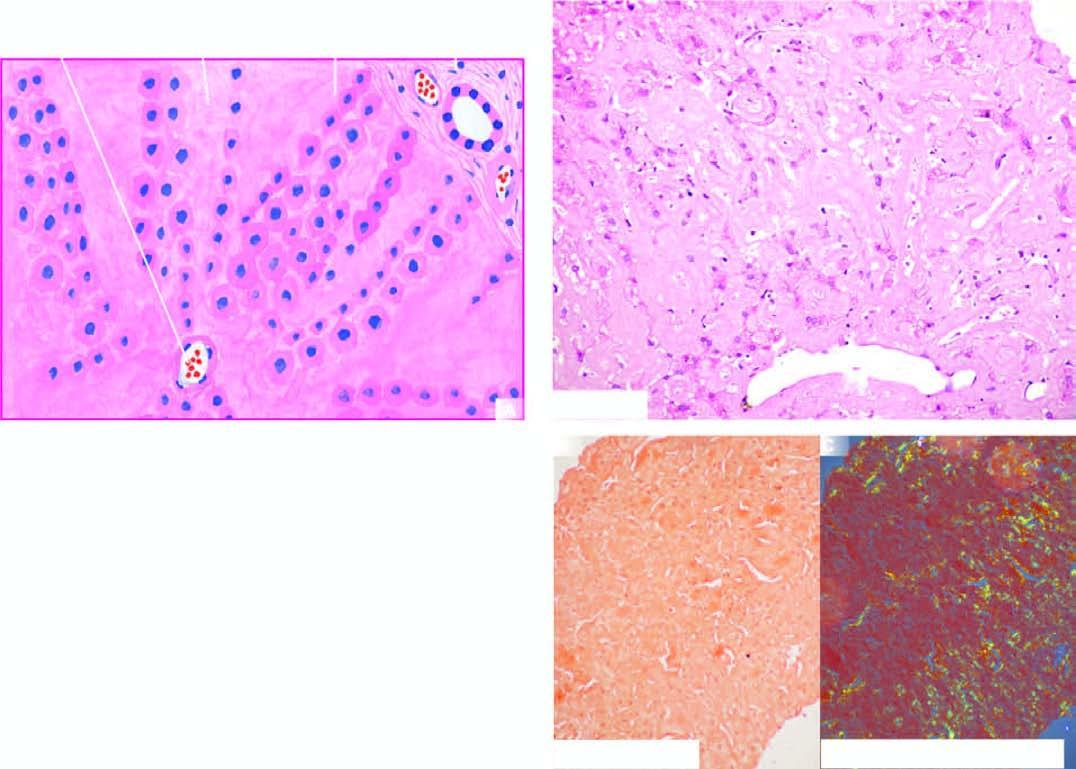does congo red staining show congophilia which under polarising microscopy?
Answer the question using a single word or phrase. Yes 